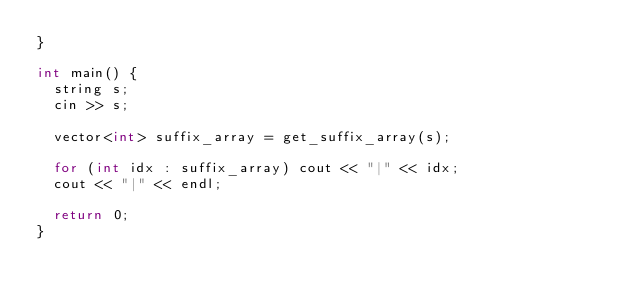Convert code to text. <code><loc_0><loc_0><loc_500><loc_500><_C++_>}

int main() {
  string s;
  cin >> s;

  vector<int> suffix_array = get_suffix_array(s);

  for (int idx : suffix_array) cout << "|" << idx;
  cout << "|" << endl;

  return 0;
}
</code> 